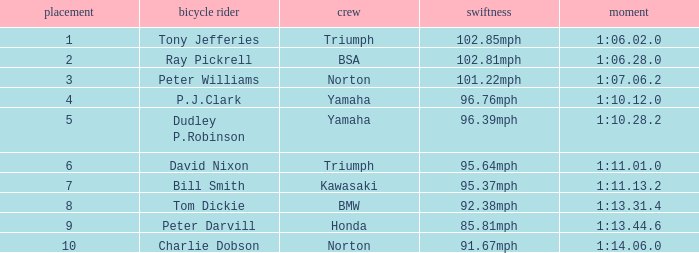At 96.76mph speed, what is the Time? 1:10.12.0. 